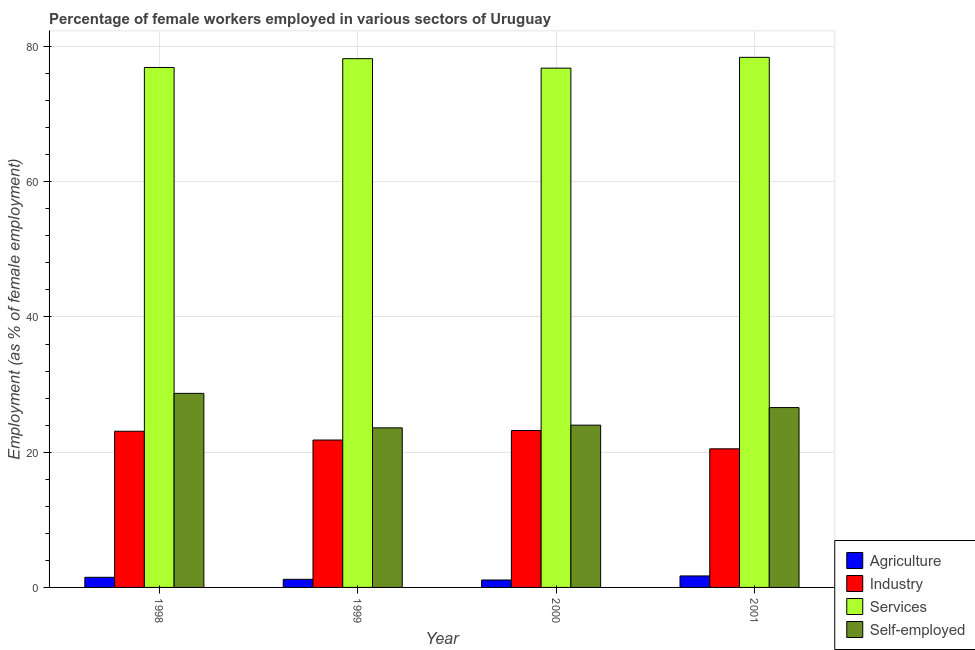How many different coloured bars are there?
Give a very brief answer. 4. Are the number of bars on each tick of the X-axis equal?
Your response must be concise. Yes. How many bars are there on the 4th tick from the right?
Offer a very short reply. 4. What is the percentage of self employed female workers in 2000?
Your answer should be compact. 24. Across all years, what is the maximum percentage of self employed female workers?
Make the answer very short. 28.7. Across all years, what is the minimum percentage of self employed female workers?
Provide a short and direct response. 23.6. In which year was the percentage of female workers in services maximum?
Make the answer very short. 2001. What is the total percentage of self employed female workers in the graph?
Offer a terse response. 102.9. What is the difference between the percentage of female workers in services in 1998 and that in 2001?
Your answer should be compact. -1.5. What is the difference between the percentage of female workers in industry in 1998 and the percentage of female workers in agriculture in 1999?
Offer a terse response. 1.3. What is the average percentage of female workers in industry per year?
Offer a very short reply. 22.15. In how many years, is the percentage of female workers in industry greater than 44 %?
Your response must be concise. 0. What is the ratio of the percentage of female workers in services in 1999 to that in 2001?
Give a very brief answer. 1. Is the difference between the percentage of female workers in agriculture in 1999 and 2000 greater than the difference between the percentage of self employed female workers in 1999 and 2000?
Offer a very short reply. No. What is the difference between the highest and the second highest percentage of female workers in services?
Give a very brief answer. 0.2. What is the difference between the highest and the lowest percentage of female workers in agriculture?
Ensure brevity in your answer.  0.6. What does the 1st bar from the left in 2000 represents?
Your answer should be very brief. Agriculture. What does the 2nd bar from the right in 1999 represents?
Ensure brevity in your answer.  Services. Is it the case that in every year, the sum of the percentage of female workers in agriculture and percentage of female workers in industry is greater than the percentage of female workers in services?
Offer a very short reply. No. How many bars are there?
Make the answer very short. 16. Are all the bars in the graph horizontal?
Give a very brief answer. No. How many years are there in the graph?
Provide a succinct answer. 4. What is the difference between two consecutive major ticks on the Y-axis?
Your response must be concise. 20. Does the graph contain any zero values?
Provide a short and direct response. No. Does the graph contain grids?
Your answer should be very brief. Yes. How are the legend labels stacked?
Keep it short and to the point. Vertical. What is the title of the graph?
Keep it short and to the point. Percentage of female workers employed in various sectors of Uruguay. What is the label or title of the X-axis?
Make the answer very short. Year. What is the label or title of the Y-axis?
Provide a succinct answer. Employment (as % of female employment). What is the Employment (as % of female employment) in Agriculture in 1998?
Offer a terse response. 1.5. What is the Employment (as % of female employment) of Industry in 1998?
Your answer should be very brief. 23.1. What is the Employment (as % of female employment) of Services in 1998?
Your response must be concise. 76.9. What is the Employment (as % of female employment) of Self-employed in 1998?
Your answer should be compact. 28.7. What is the Employment (as % of female employment) of Agriculture in 1999?
Offer a terse response. 1.2. What is the Employment (as % of female employment) of Industry in 1999?
Keep it short and to the point. 21.8. What is the Employment (as % of female employment) of Services in 1999?
Your response must be concise. 78.2. What is the Employment (as % of female employment) in Self-employed in 1999?
Give a very brief answer. 23.6. What is the Employment (as % of female employment) in Agriculture in 2000?
Your answer should be very brief. 1.1. What is the Employment (as % of female employment) of Industry in 2000?
Provide a short and direct response. 23.2. What is the Employment (as % of female employment) in Services in 2000?
Make the answer very short. 76.8. What is the Employment (as % of female employment) of Agriculture in 2001?
Give a very brief answer. 1.7. What is the Employment (as % of female employment) in Services in 2001?
Your answer should be compact. 78.4. What is the Employment (as % of female employment) in Self-employed in 2001?
Your answer should be compact. 26.6. Across all years, what is the maximum Employment (as % of female employment) of Agriculture?
Offer a terse response. 1.7. Across all years, what is the maximum Employment (as % of female employment) in Industry?
Provide a succinct answer. 23.2. Across all years, what is the maximum Employment (as % of female employment) in Services?
Keep it short and to the point. 78.4. Across all years, what is the maximum Employment (as % of female employment) of Self-employed?
Provide a succinct answer. 28.7. Across all years, what is the minimum Employment (as % of female employment) in Agriculture?
Your answer should be compact. 1.1. Across all years, what is the minimum Employment (as % of female employment) in Services?
Offer a very short reply. 76.8. Across all years, what is the minimum Employment (as % of female employment) of Self-employed?
Give a very brief answer. 23.6. What is the total Employment (as % of female employment) in Agriculture in the graph?
Give a very brief answer. 5.5. What is the total Employment (as % of female employment) in Industry in the graph?
Keep it short and to the point. 88.6. What is the total Employment (as % of female employment) of Services in the graph?
Offer a very short reply. 310.3. What is the total Employment (as % of female employment) in Self-employed in the graph?
Offer a very short reply. 102.9. What is the difference between the Employment (as % of female employment) of Agriculture in 1998 and that in 1999?
Offer a very short reply. 0.3. What is the difference between the Employment (as % of female employment) in Self-employed in 1998 and that in 1999?
Your answer should be very brief. 5.1. What is the difference between the Employment (as % of female employment) of Agriculture in 1998 and that in 2000?
Make the answer very short. 0.4. What is the difference between the Employment (as % of female employment) of Industry in 1998 and that in 2000?
Offer a very short reply. -0.1. What is the difference between the Employment (as % of female employment) of Self-employed in 1998 and that in 2000?
Make the answer very short. 4.7. What is the difference between the Employment (as % of female employment) of Services in 1998 and that in 2001?
Your answer should be compact. -1.5. What is the difference between the Employment (as % of female employment) of Industry in 1999 and that in 2000?
Your answer should be compact. -1.4. What is the difference between the Employment (as % of female employment) of Services in 1999 and that in 2000?
Your response must be concise. 1.4. What is the difference between the Employment (as % of female employment) of Self-employed in 1999 and that in 2000?
Keep it short and to the point. -0.4. What is the difference between the Employment (as % of female employment) in Self-employed in 1999 and that in 2001?
Provide a succinct answer. -3. What is the difference between the Employment (as % of female employment) in Agriculture in 2000 and that in 2001?
Provide a short and direct response. -0.6. What is the difference between the Employment (as % of female employment) in Services in 2000 and that in 2001?
Your answer should be very brief. -1.6. What is the difference between the Employment (as % of female employment) of Agriculture in 1998 and the Employment (as % of female employment) of Industry in 1999?
Give a very brief answer. -20.3. What is the difference between the Employment (as % of female employment) of Agriculture in 1998 and the Employment (as % of female employment) of Services in 1999?
Provide a succinct answer. -76.7. What is the difference between the Employment (as % of female employment) in Agriculture in 1998 and the Employment (as % of female employment) in Self-employed in 1999?
Your response must be concise. -22.1. What is the difference between the Employment (as % of female employment) of Industry in 1998 and the Employment (as % of female employment) of Services in 1999?
Ensure brevity in your answer.  -55.1. What is the difference between the Employment (as % of female employment) in Industry in 1998 and the Employment (as % of female employment) in Self-employed in 1999?
Your answer should be compact. -0.5. What is the difference between the Employment (as % of female employment) of Services in 1998 and the Employment (as % of female employment) of Self-employed in 1999?
Give a very brief answer. 53.3. What is the difference between the Employment (as % of female employment) of Agriculture in 1998 and the Employment (as % of female employment) of Industry in 2000?
Give a very brief answer. -21.7. What is the difference between the Employment (as % of female employment) of Agriculture in 1998 and the Employment (as % of female employment) of Services in 2000?
Offer a very short reply. -75.3. What is the difference between the Employment (as % of female employment) in Agriculture in 1998 and the Employment (as % of female employment) in Self-employed in 2000?
Your answer should be compact. -22.5. What is the difference between the Employment (as % of female employment) of Industry in 1998 and the Employment (as % of female employment) of Services in 2000?
Provide a short and direct response. -53.7. What is the difference between the Employment (as % of female employment) of Services in 1998 and the Employment (as % of female employment) of Self-employed in 2000?
Offer a terse response. 52.9. What is the difference between the Employment (as % of female employment) of Agriculture in 1998 and the Employment (as % of female employment) of Services in 2001?
Offer a very short reply. -76.9. What is the difference between the Employment (as % of female employment) of Agriculture in 1998 and the Employment (as % of female employment) of Self-employed in 2001?
Keep it short and to the point. -25.1. What is the difference between the Employment (as % of female employment) in Industry in 1998 and the Employment (as % of female employment) in Services in 2001?
Ensure brevity in your answer.  -55.3. What is the difference between the Employment (as % of female employment) of Services in 1998 and the Employment (as % of female employment) of Self-employed in 2001?
Your answer should be very brief. 50.3. What is the difference between the Employment (as % of female employment) in Agriculture in 1999 and the Employment (as % of female employment) in Services in 2000?
Provide a short and direct response. -75.6. What is the difference between the Employment (as % of female employment) of Agriculture in 1999 and the Employment (as % of female employment) of Self-employed in 2000?
Provide a succinct answer. -22.8. What is the difference between the Employment (as % of female employment) in Industry in 1999 and the Employment (as % of female employment) in Services in 2000?
Keep it short and to the point. -55. What is the difference between the Employment (as % of female employment) in Services in 1999 and the Employment (as % of female employment) in Self-employed in 2000?
Keep it short and to the point. 54.2. What is the difference between the Employment (as % of female employment) in Agriculture in 1999 and the Employment (as % of female employment) in Industry in 2001?
Give a very brief answer. -19.3. What is the difference between the Employment (as % of female employment) in Agriculture in 1999 and the Employment (as % of female employment) in Services in 2001?
Offer a very short reply. -77.2. What is the difference between the Employment (as % of female employment) of Agriculture in 1999 and the Employment (as % of female employment) of Self-employed in 2001?
Keep it short and to the point. -25.4. What is the difference between the Employment (as % of female employment) of Industry in 1999 and the Employment (as % of female employment) of Services in 2001?
Offer a terse response. -56.6. What is the difference between the Employment (as % of female employment) of Industry in 1999 and the Employment (as % of female employment) of Self-employed in 2001?
Make the answer very short. -4.8. What is the difference between the Employment (as % of female employment) in Services in 1999 and the Employment (as % of female employment) in Self-employed in 2001?
Offer a terse response. 51.6. What is the difference between the Employment (as % of female employment) of Agriculture in 2000 and the Employment (as % of female employment) of Industry in 2001?
Your response must be concise. -19.4. What is the difference between the Employment (as % of female employment) in Agriculture in 2000 and the Employment (as % of female employment) in Services in 2001?
Make the answer very short. -77.3. What is the difference between the Employment (as % of female employment) of Agriculture in 2000 and the Employment (as % of female employment) of Self-employed in 2001?
Your answer should be compact. -25.5. What is the difference between the Employment (as % of female employment) in Industry in 2000 and the Employment (as % of female employment) in Services in 2001?
Provide a short and direct response. -55.2. What is the difference between the Employment (as % of female employment) of Services in 2000 and the Employment (as % of female employment) of Self-employed in 2001?
Your answer should be compact. 50.2. What is the average Employment (as % of female employment) of Agriculture per year?
Provide a succinct answer. 1.38. What is the average Employment (as % of female employment) in Industry per year?
Ensure brevity in your answer.  22.15. What is the average Employment (as % of female employment) in Services per year?
Offer a terse response. 77.58. What is the average Employment (as % of female employment) of Self-employed per year?
Your answer should be very brief. 25.73. In the year 1998, what is the difference between the Employment (as % of female employment) in Agriculture and Employment (as % of female employment) in Industry?
Give a very brief answer. -21.6. In the year 1998, what is the difference between the Employment (as % of female employment) of Agriculture and Employment (as % of female employment) of Services?
Give a very brief answer. -75.4. In the year 1998, what is the difference between the Employment (as % of female employment) in Agriculture and Employment (as % of female employment) in Self-employed?
Ensure brevity in your answer.  -27.2. In the year 1998, what is the difference between the Employment (as % of female employment) in Industry and Employment (as % of female employment) in Services?
Give a very brief answer. -53.8. In the year 1998, what is the difference between the Employment (as % of female employment) of Services and Employment (as % of female employment) of Self-employed?
Provide a succinct answer. 48.2. In the year 1999, what is the difference between the Employment (as % of female employment) of Agriculture and Employment (as % of female employment) of Industry?
Give a very brief answer. -20.6. In the year 1999, what is the difference between the Employment (as % of female employment) in Agriculture and Employment (as % of female employment) in Services?
Your answer should be compact. -77. In the year 1999, what is the difference between the Employment (as % of female employment) of Agriculture and Employment (as % of female employment) of Self-employed?
Give a very brief answer. -22.4. In the year 1999, what is the difference between the Employment (as % of female employment) in Industry and Employment (as % of female employment) in Services?
Your response must be concise. -56.4. In the year 1999, what is the difference between the Employment (as % of female employment) of Services and Employment (as % of female employment) of Self-employed?
Give a very brief answer. 54.6. In the year 2000, what is the difference between the Employment (as % of female employment) in Agriculture and Employment (as % of female employment) in Industry?
Your response must be concise. -22.1. In the year 2000, what is the difference between the Employment (as % of female employment) in Agriculture and Employment (as % of female employment) in Services?
Offer a terse response. -75.7. In the year 2000, what is the difference between the Employment (as % of female employment) in Agriculture and Employment (as % of female employment) in Self-employed?
Offer a very short reply. -22.9. In the year 2000, what is the difference between the Employment (as % of female employment) in Industry and Employment (as % of female employment) in Services?
Offer a terse response. -53.6. In the year 2000, what is the difference between the Employment (as % of female employment) in Industry and Employment (as % of female employment) in Self-employed?
Make the answer very short. -0.8. In the year 2000, what is the difference between the Employment (as % of female employment) in Services and Employment (as % of female employment) in Self-employed?
Give a very brief answer. 52.8. In the year 2001, what is the difference between the Employment (as % of female employment) of Agriculture and Employment (as % of female employment) of Industry?
Keep it short and to the point. -18.8. In the year 2001, what is the difference between the Employment (as % of female employment) of Agriculture and Employment (as % of female employment) of Services?
Provide a succinct answer. -76.7. In the year 2001, what is the difference between the Employment (as % of female employment) of Agriculture and Employment (as % of female employment) of Self-employed?
Your answer should be compact. -24.9. In the year 2001, what is the difference between the Employment (as % of female employment) of Industry and Employment (as % of female employment) of Services?
Offer a terse response. -57.9. In the year 2001, what is the difference between the Employment (as % of female employment) of Industry and Employment (as % of female employment) of Self-employed?
Keep it short and to the point. -6.1. In the year 2001, what is the difference between the Employment (as % of female employment) in Services and Employment (as % of female employment) in Self-employed?
Make the answer very short. 51.8. What is the ratio of the Employment (as % of female employment) in Agriculture in 1998 to that in 1999?
Offer a very short reply. 1.25. What is the ratio of the Employment (as % of female employment) of Industry in 1998 to that in 1999?
Offer a terse response. 1.06. What is the ratio of the Employment (as % of female employment) of Services in 1998 to that in 1999?
Ensure brevity in your answer.  0.98. What is the ratio of the Employment (as % of female employment) in Self-employed in 1998 to that in 1999?
Ensure brevity in your answer.  1.22. What is the ratio of the Employment (as % of female employment) in Agriculture in 1998 to that in 2000?
Your answer should be compact. 1.36. What is the ratio of the Employment (as % of female employment) in Self-employed in 1998 to that in 2000?
Offer a terse response. 1.2. What is the ratio of the Employment (as % of female employment) of Agriculture in 1998 to that in 2001?
Your response must be concise. 0.88. What is the ratio of the Employment (as % of female employment) in Industry in 1998 to that in 2001?
Make the answer very short. 1.13. What is the ratio of the Employment (as % of female employment) in Services in 1998 to that in 2001?
Your answer should be very brief. 0.98. What is the ratio of the Employment (as % of female employment) of Self-employed in 1998 to that in 2001?
Your answer should be very brief. 1.08. What is the ratio of the Employment (as % of female employment) in Agriculture in 1999 to that in 2000?
Offer a very short reply. 1.09. What is the ratio of the Employment (as % of female employment) of Industry in 1999 to that in 2000?
Ensure brevity in your answer.  0.94. What is the ratio of the Employment (as % of female employment) in Services in 1999 to that in 2000?
Keep it short and to the point. 1.02. What is the ratio of the Employment (as % of female employment) of Self-employed in 1999 to that in 2000?
Your answer should be compact. 0.98. What is the ratio of the Employment (as % of female employment) in Agriculture in 1999 to that in 2001?
Make the answer very short. 0.71. What is the ratio of the Employment (as % of female employment) in Industry in 1999 to that in 2001?
Your answer should be very brief. 1.06. What is the ratio of the Employment (as % of female employment) of Services in 1999 to that in 2001?
Your answer should be compact. 1. What is the ratio of the Employment (as % of female employment) in Self-employed in 1999 to that in 2001?
Offer a very short reply. 0.89. What is the ratio of the Employment (as % of female employment) in Agriculture in 2000 to that in 2001?
Make the answer very short. 0.65. What is the ratio of the Employment (as % of female employment) in Industry in 2000 to that in 2001?
Offer a terse response. 1.13. What is the ratio of the Employment (as % of female employment) in Services in 2000 to that in 2001?
Ensure brevity in your answer.  0.98. What is the ratio of the Employment (as % of female employment) of Self-employed in 2000 to that in 2001?
Offer a very short reply. 0.9. What is the difference between the highest and the second highest Employment (as % of female employment) in Services?
Make the answer very short. 0.2. What is the difference between the highest and the lowest Employment (as % of female employment) in Services?
Your response must be concise. 1.6. What is the difference between the highest and the lowest Employment (as % of female employment) in Self-employed?
Make the answer very short. 5.1. 